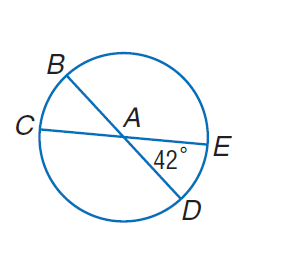Answer the mathemtical geometry problem and directly provide the correct option letter.
Question: In \odot A, m \angle E A D = 42. Find m \widehat E D B.
Choices: A: 120 B: 138 C: 222 D: 240 C 